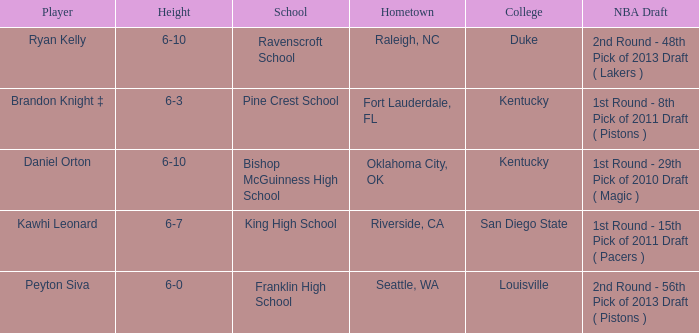Which school is in Raleigh, NC? Ravenscroft School. 